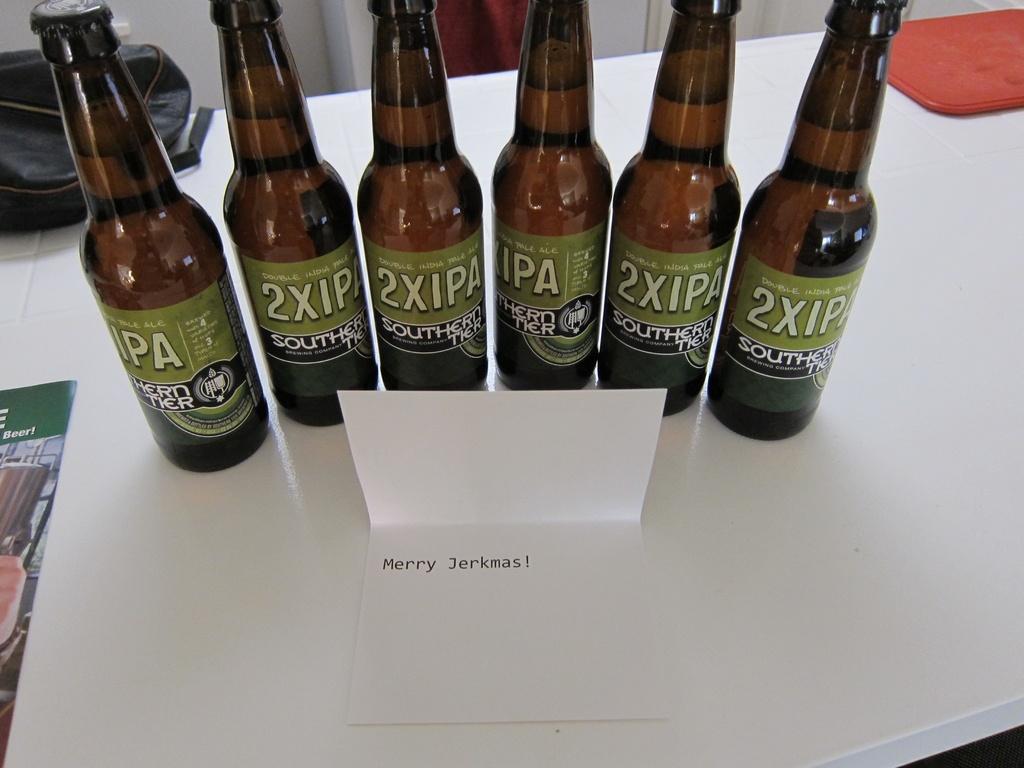What does the card say?
Give a very brief answer. Merry jerkmas. 